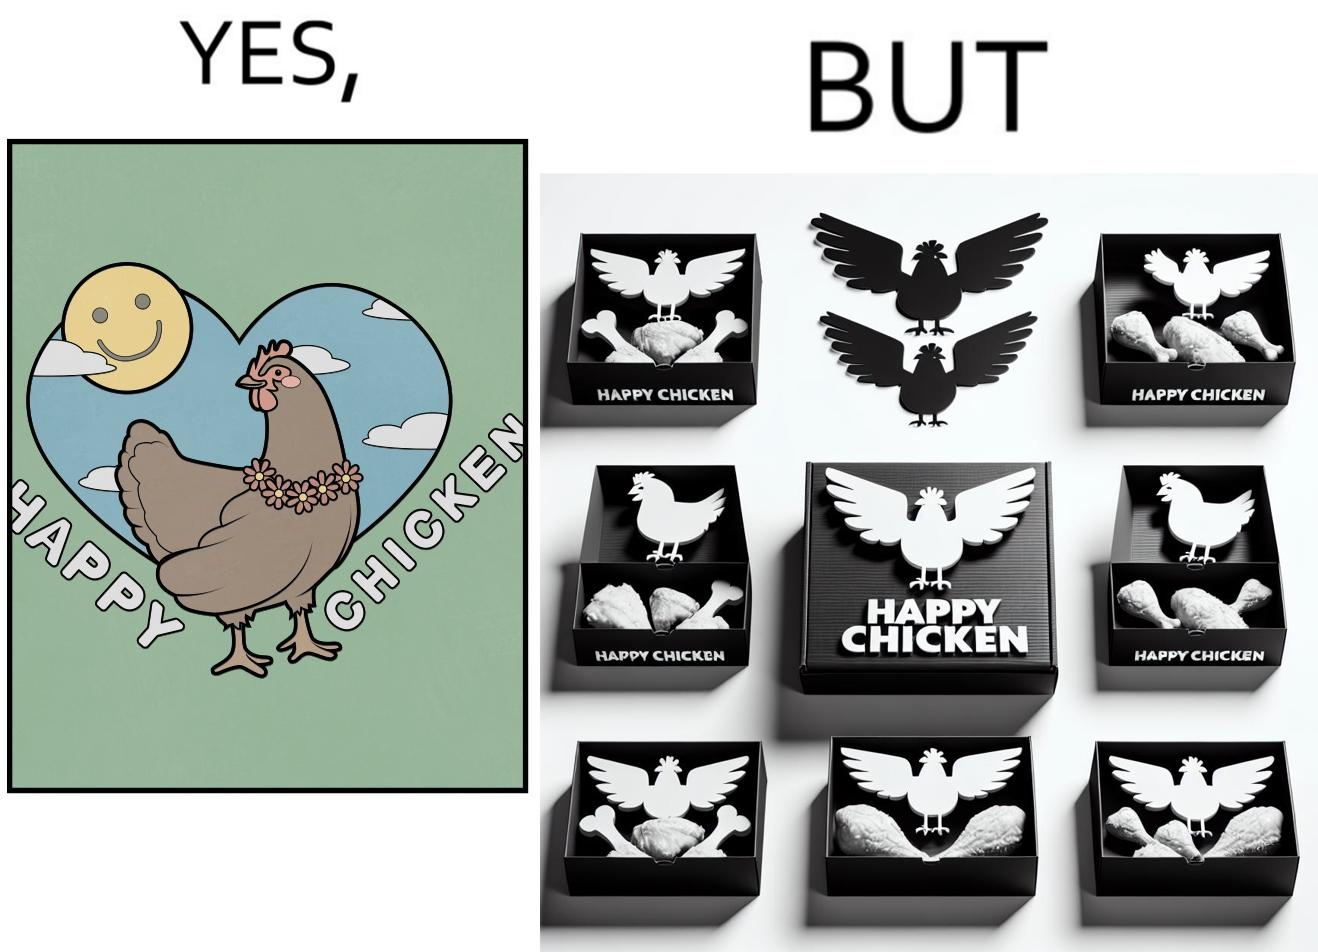Is this a satirical image? Yes, this image is satirical. 